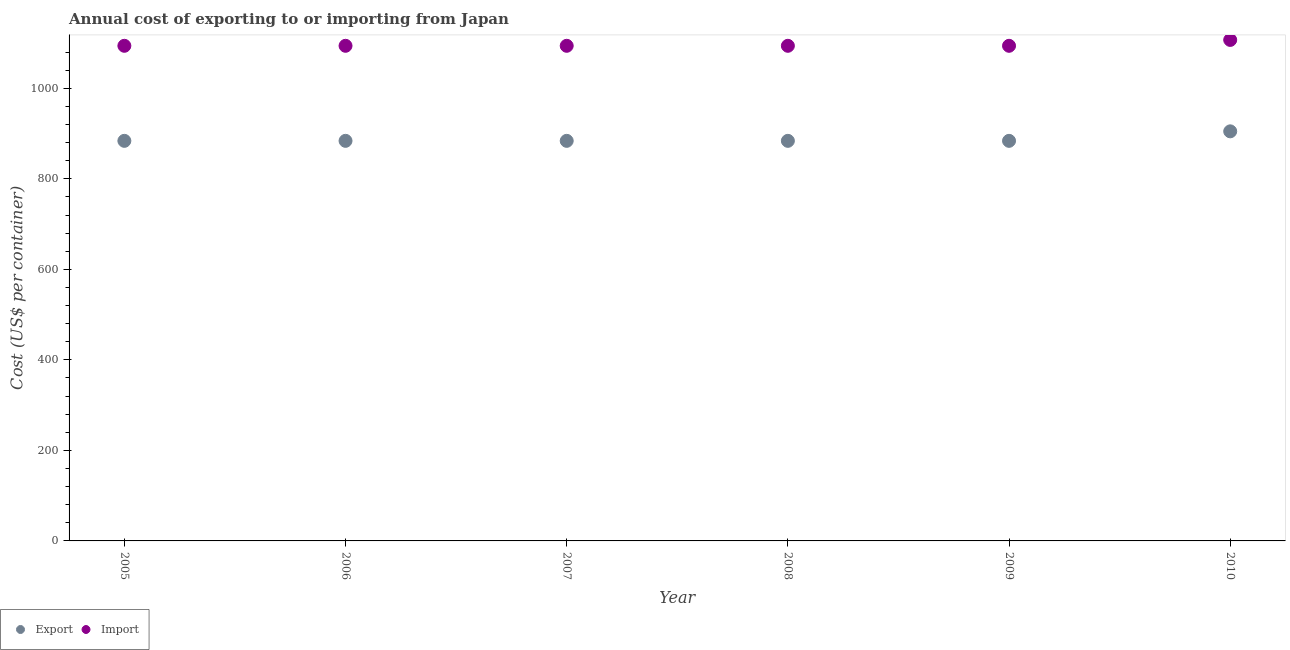How many different coloured dotlines are there?
Offer a terse response. 2. Is the number of dotlines equal to the number of legend labels?
Offer a terse response. Yes. What is the export cost in 2009?
Offer a terse response. 884. Across all years, what is the maximum import cost?
Provide a short and direct response. 1107. Across all years, what is the minimum export cost?
Offer a very short reply. 884. In which year was the import cost maximum?
Provide a short and direct response. 2010. What is the total import cost in the graph?
Provide a succinct answer. 6577. What is the difference between the export cost in 2005 and the import cost in 2009?
Make the answer very short. -210. What is the average import cost per year?
Provide a short and direct response. 1096.17. In the year 2009, what is the difference between the import cost and export cost?
Your answer should be compact. 210. In how many years, is the import cost greater than 1040 US$?
Your answer should be compact. 6. What is the ratio of the export cost in 2005 to that in 2009?
Make the answer very short. 1. Is the export cost in 2006 less than that in 2007?
Your answer should be very brief. No. What is the difference between the highest and the second highest import cost?
Offer a very short reply. 13. What is the difference between the highest and the lowest export cost?
Make the answer very short. 21. In how many years, is the export cost greater than the average export cost taken over all years?
Your answer should be compact. 1. Is the sum of the export cost in 2005 and 2010 greater than the maximum import cost across all years?
Offer a terse response. Yes. Does the import cost monotonically increase over the years?
Ensure brevity in your answer.  No. Is the export cost strictly greater than the import cost over the years?
Keep it short and to the point. No. How many dotlines are there?
Your answer should be compact. 2. How many years are there in the graph?
Offer a terse response. 6. Does the graph contain any zero values?
Offer a very short reply. No. How are the legend labels stacked?
Offer a very short reply. Horizontal. What is the title of the graph?
Offer a very short reply. Annual cost of exporting to or importing from Japan. Does "Money lenders" appear as one of the legend labels in the graph?
Your answer should be very brief. No. What is the label or title of the Y-axis?
Offer a terse response. Cost (US$ per container). What is the Cost (US$ per container) in Export in 2005?
Your response must be concise. 884. What is the Cost (US$ per container) of Import in 2005?
Ensure brevity in your answer.  1094. What is the Cost (US$ per container) of Export in 2006?
Offer a very short reply. 884. What is the Cost (US$ per container) in Import in 2006?
Your answer should be compact. 1094. What is the Cost (US$ per container) in Export in 2007?
Your answer should be very brief. 884. What is the Cost (US$ per container) in Import in 2007?
Your answer should be very brief. 1094. What is the Cost (US$ per container) of Export in 2008?
Give a very brief answer. 884. What is the Cost (US$ per container) in Import in 2008?
Your answer should be compact. 1094. What is the Cost (US$ per container) in Export in 2009?
Keep it short and to the point. 884. What is the Cost (US$ per container) of Import in 2009?
Your answer should be compact. 1094. What is the Cost (US$ per container) of Export in 2010?
Your response must be concise. 905. What is the Cost (US$ per container) in Import in 2010?
Your answer should be compact. 1107. Across all years, what is the maximum Cost (US$ per container) of Export?
Keep it short and to the point. 905. Across all years, what is the maximum Cost (US$ per container) in Import?
Provide a succinct answer. 1107. Across all years, what is the minimum Cost (US$ per container) of Export?
Make the answer very short. 884. Across all years, what is the minimum Cost (US$ per container) of Import?
Your response must be concise. 1094. What is the total Cost (US$ per container) of Export in the graph?
Provide a succinct answer. 5325. What is the total Cost (US$ per container) of Import in the graph?
Offer a very short reply. 6577. What is the difference between the Cost (US$ per container) in Import in 2005 and that in 2007?
Your response must be concise. 0. What is the difference between the Cost (US$ per container) in Export in 2005 and that in 2008?
Make the answer very short. 0. What is the difference between the Cost (US$ per container) of Import in 2005 and that in 2008?
Make the answer very short. 0. What is the difference between the Cost (US$ per container) of Import in 2005 and that in 2009?
Make the answer very short. 0. What is the difference between the Cost (US$ per container) of Import in 2006 and that in 2007?
Provide a short and direct response. 0. What is the difference between the Cost (US$ per container) of Export in 2006 and that in 2008?
Your answer should be compact. 0. What is the difference between the Cost (US$ per container) in Export in 2006 and that in 2009?
Offer a terse response. 0. What is the difference between the Cost (US$ per container) in Import in 2006 and that in 2009?
Make the answer very short. 0. What is the difference between the Cost (US$ per container) in Export in 2006 and that in 2010?
Make the answer very short. -21. What is the difference between the Cost (US$ per container) of Import in 2007 and that in 2008?
Offer a terse response. 0. What is the difference between the Cost (US$ per container) in Export in 2007 and that in 2009?
Your answer should be very brief. 0. What is the difference between the Cost (US$ per container) in Export in 2007 and that in 2010?
Offer a terse response. -21. What is the difference between the Cost (US$ per container) of Import in 2008 and that in 2009?
Provide a succinct answer. 0. What is the difference between the Cost (US$ per container) in Export in 2008 and that in 2010?
Make the answer very short. -21. What is the difference between the Cost (US$ per container) of Import in 2009 and that in 2010?
Your response must be concise. -13. What is the difference between the Cost (US$ per container) of Export in 2005 and the Cost (US$ per container) of Import in 2006?
Give a very brief answer. -210. What is the difference between the Cost (US$ per container) of Export in 2005 and the Cost (US$ per container) of Import in 2007?
Keep it short and to the point. -210. What is the difference between the Cost (US$ per container) in Export in 2005 and the Cost (US$ per container) in Import in 2008?
Provide a short and direct response. -210. What is the difference between the Cost (US$ per container) of Export in 2005 and the Cost (US$ per container) of Import in 2009?
Provide a short and direct response. -210. What is the difference between the Cost (US$ per container) in Export in 2005 and the Cost (US$ per container) in Import in 2010?
Your answer should be very brief. -223. What is the difference between the Cost (US$ per container) in Export in 2006 and the Cost (US$ per container) in Import in 2007?
Your answer should be compact. -210. What is the difference between the Cost (US$ per container) in Export in 2006 and the Cost (US$ per container) in Import in 2008?
Keep it short and to the point. -210. What is the difference between the Cost (US$ per container) of Export in 2006 and the Cost (US$ per container) of Import in 2009?
Your response must be concise. -210. What is the difference between the Cost (US$ per container) in Export in 2006 and the Cost (US$ per container) in Import in 2010?
Offer a very short reply. -223. What is the difference between the Cost (US$ per container) in Export in 2007 and the Cost (US$ per container) in Import in 2008?
Your response must be concise. -210. What is the difference between the Cost (US$ per container) in Export in 2007 and the Cost (US$ per container) in Import in 2009?
Provide a succinct answer. -210. What is the difference between the Cost (US$ per container) in Export in 2007 and the Cost (US$ per container) in Import in 2010?
Your response must be concise. -223. What is the difference between the Cost (US$ per container) in Export in 2008 and the Cost (US$ per container) in Import in 2009?
Your answer should be very brief. -210. What is the difference between the Cost (US$ per container) of Export in 2008 and the Cost (US$ per container) of Import in 2010?
Your answer should be compact. -223. What is the difference between the Cost (US$ per container) of Export in 2009 and the Cost (US$ per container) of Import in 2010?
Your answer should be very brief. -223. What is the average Cost (US$ per container) in Export per year?
Give a very brief answer. 887.5. What is the average Cost (US$ per container) of Import per year?
Ensure brevity in your answer.  1096.17. In the year 2005, what is the difference between the Cost (US$ per container) in Export and Cost (US$ per container) in Import?
Offer a very short reply. -210. In the year 2006, what is the difference between the Cost (US$ per container) in Export and Cost (US$ per container) in Import?
Ensure brevity in your answer.  -210. In the year 2007, what is the difference between the Cost (US$ per container) of Export and Cost (US$ per container) of Import?
Provide a short and direct response. -210. In the year 2008, what is the difference between the Cost (US$ per container) in Export and Cost (US$ per container) in Import?
Give a very brief answer. -210. In the year 2009, what is the difference between the Cost (US$ per container) in Export and Cost (US$ per container) in Import?
Provide a short and direct response. -210. In the year 2010, what is the difference between the Cost (US$ per container) of Export and Cost (US$ per container) of Import?
Ensure brevity in your answer.  -202. What is the ratio of the Cost (US$ per container) in Export in 2005 to that in 2007?
Offer a terse response. 1. What is the ratio of the Cost (US$ per container) of Import in 2005 to that in 2007?
Your answer should be compact. 1. What is the ratio of the Cost (US$ per container) in Export in 2005 to that in 2008?
Your answer should be compact. 1. What is the ratio of the Cost (US$ per container) of Import in 2005 to that in 2008?
Keep it short and to the point. 1. What is the ratio of the Cost (US$ per container) in Export in 2005 to that in 2009?
Provide a succinct answer. 1. What is the ratio of the Cost (US$ per container) in Import in 2005 to that in 2009?
Offer a terse response. 1. What is the ratio of the Cost (US$ per container) of Export in 2005 to that in 2010?
Ensure brevity in your answer.  0.98. What is the ratio of the Cost (US$ per container) in Import in 2005 to that in 2010?
Give a very brief answer. 0.99. What is the ratio of the Cost (US$ per container) of Export in 2006 to that in 2008?
Give a very brief answer. 1. What is the ratio of the Cost (US$ per container) in Import in 2006 to that in 2008?
Make the answer very short. 1. What is the ratio of the Cost (US$ per container) in Export in 2006 to that in 2010?
Your answer should be very brief. 0.98. What is the ratio of the Cost (US$ per container) of Import in 2006 to that in 2010?
Your answer should be compact. 0.99. What is the ratio of the Cost (US$ per container) in Export in 2007 to that in 2008?
Keep it short and to the point. 1. What is the ratio of the Cost (US$ per container) of Export in 2007 to that in 2009?
Your answer should be compact. 1. What is the ratio of the Cost (US$ per container) in Import in 2007 to that in 2009?
Keep it short and to the point. 1. What is the ratio of the Cost (US$ per container) in Export in 2007 to that in 2010?
Ensure brevity in your answer.  0.98. What is the ratio of the Cost (US$ per container) of Import in 2007 to that in 2010?
Your answer should be very brief. 0.99. What is the ratio of the Cost (US$ per container) of Import in 2008 to that in 2009?
Keep it short and to the point. 1. What is the ratio of the Cost (US$ per container) of Export in 2008 to that in 2010?
Give a very brief answer. 0.98. What is the ratio of the Cost (US$ per container) in Import in 2008 to that in 2010?
Keep it short and to the point. 0.99. What is the ratio of the Cost (US$ per container) of Export in 2009 to that in 2010?
Your answer should be compact. 0.98. What is the ratio of the Cost (US$ per container) in Import in 2009 to that in 2010?
Give a very brief answer. 0.99. What is the difference between the highest and the second highest Cost (US$ per container) in Export?
Offer a terse response. 21. What is the difference between the highest and the lowest Cost (US$ per container) in Export?
Offer a terse response. 21. 